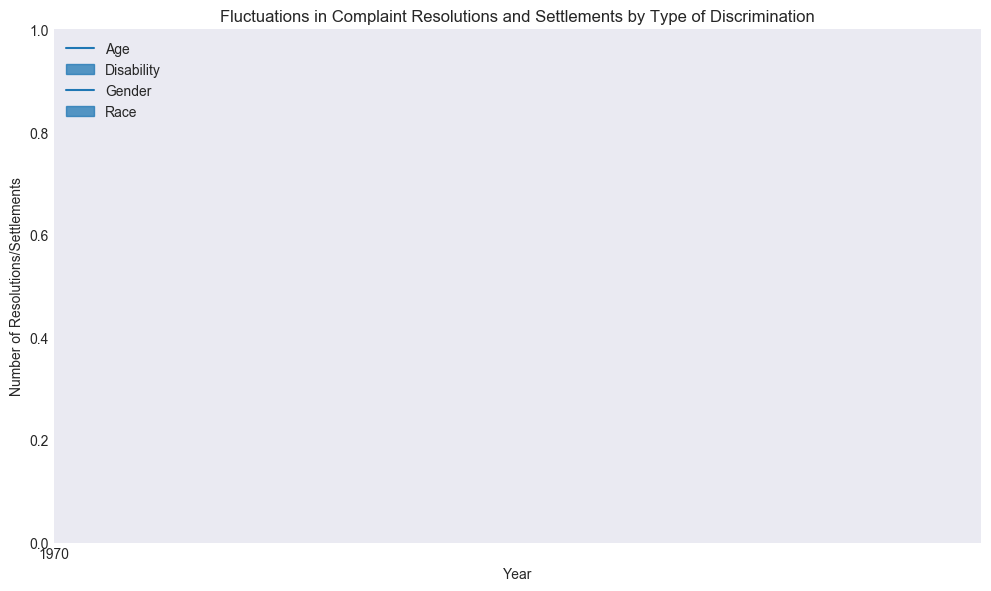Which type of discrimination saw the highest number of complaint resolutions in 2022? In the year 2022, the high point for each type of discrimination is represented by the top of the vertical line in the candlestick. The highest number is for Race, which is 47.
Answer: Race How did the number of complaint resolutions for Age discrimination change from 2018 to 2022? Starting in 2018, Age discrimination opened at 15 and closed at 22. By 2022, it opened at 22 and closed at 30. This shows an upward trend.
Answer: Increased Which type of discrimination showed the most fluctuation in complaint resolutions in 2021? Fluctuation can be seen by looking at the difference between the high and low values. In 2021, Race discrimination had the highest fluctuation with a range from 45 - 25 = 20.
Answer: Race Compare the closing value of Gender discrimination in 2020 with the opening value in 2021. Is it higher, lower, or the same? In 2020, Gender discrimination closed at 27. In 2021, it opened at 24. Comparing 27 and 24, the closing value in 2020 is higher than the opening value in 2021.
Answer: Higher What is the average closing value across all types of discrimination in 2019? The closing values for 2019 are: Age (25), Disability (15), Gender (30), and Race (35). Compute the average: (25 + 15 + 30 + 35) / 4 = 26.25.
Answer: 26.25 Which type of discrimination had the smallest increase in its closing value from 2018 to 2022? Calculate the difference for each type: Age (30 - 22 = 8), Disability (18 - 13 = 5), Gender (34 - 28 = 6), Race (42 - 32 = 10). The smallest increase is in Disability, with an increase of 5.
Answer: Disability Is there any year where Gender discrimination had the highest closing value among all types? Look at the closing values for Gender discrimination across the years and compare with others. In 2021, Gender discrimination had a closing value of 33, which is lower than Race at 40. No year qualifies.
Answer: No What was the closing value for Disability discrimination in 2020 and how does it compare to the opening value in the same year? In 2020, Disability discrimination had an opening value of 11 and a closing value of 14. To compare: 14 - 11 = 3 increase.
Answer: 14, Increased Which type of discrimination had the highest low value in 2019 and what was that value? The low values for 2019 are: Age (15), Disability (10), Gender (19), and Race (22). The highest low value is for Race, which is 22.
Answer: Race Compare the range of settlement values for Age discrimination between 2018 and 2022. Which year had a larger range? The range is the difference between the high and low values. For Age discrimination, 2018 range is 27 - 13 = 14, and 2022 range is 33 - 19 = 14. Since both ranges are equal, no year had a larger range.
Answer: Both are equal 